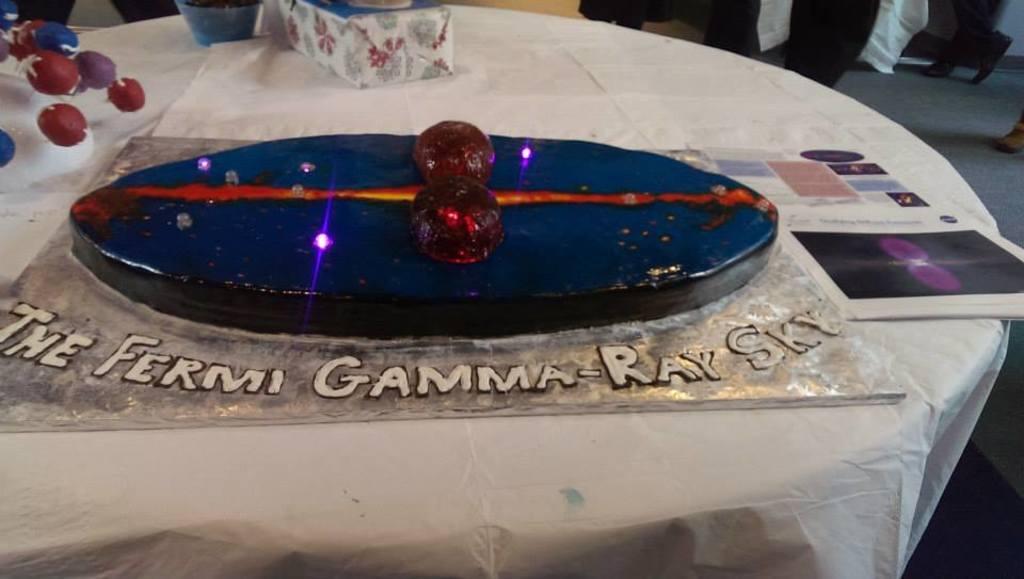Describe this image in one or two sentences. This picture seems to be clicked inside the room. In the foreground we can see a table on the top of which gift box, cake and some other items are placed. In the background we can see the group of people and some other items. 